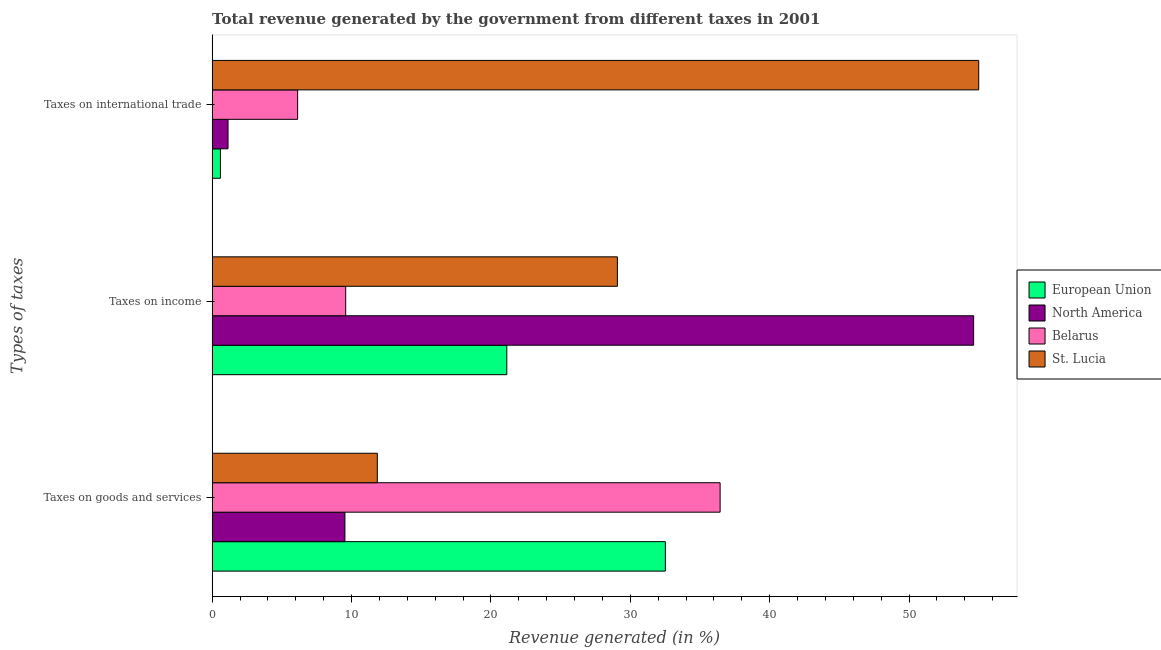How many groups of bars are there?
Provide a succinct answer. 3. How many bars are there on the 3rd tick from the top?
Offer a very short reply. 4. How many bars are there on the 2nd tick from the bottom?
Your answer should be very brief. 4. What is the label of the 2nd group of bars from the top?
Make the answer very short. Taxes on income. What is the percentage of revenue generated by taxes on income in St. Lucia?
Offer a very short reply. 29.08. Across all countries, what is the maximum percentage of revenue generated by taxes on income?
Offer a terse response. 54.64. Across all countries, what is the minimum percentage of revenue generated by taxes on income?
Offer a very short reply. 9.58. In which country was the percentage of revenue generated by taxes on goods and services minimum?
Your answer should be compact. North America. What is the total percentage of revenue generated by taxes on goods and services in the graph?
Make the answer very short. 90.35. What is the difference between the percentage of revenue generated by taxes on income in St. Lucia and that in Belarus?
Your response must be concise. 19.5. What is the difference between the percentage of revenue generated by taxes on goods and services in St. Lucia and the percentage of revenue generated by tax on international trade in European Union?
Your answer should be very brief. 11.26. What is the average percentage of revenue generated by taxes on goods and services per country?
Your answer should be compact. 22.59. What is the difference between the percentage of revenue generated by taxes on goods and services and percentage of revenue generated by tax on international trade in Belarus?
Your answer should be compact. 30.31. What is the ratio of the percentage of revenue generated by taxes on goods and services in European Union to that in St. Lucia?
Keep it short and to the point. 2.74. Is the difference between the percentage of revenue generated by taxes on goods and services in Belarus and European Union greater than the difference between the percentage of revenue generated by taxes on income in Belarus and European Union?
Provide a succinct answer. Yes. What is the difference between the highest and the second highest percentage of revenue generated by taxes on goods and services?
Give a very brief answer. 3.93. What is the difference between the highest and the lowest percentage of revenue generated by taxes on income?
Offer a very short reply. 45.05. What does the 4th bar from the bottom in Taxes on income represents?
Keep it short and to the point. St. Lucia. Is it the case that in every country, the sum of the percentage of revenue generated by taxes on goods and services and percentage of revenue generated by taxes on income is greater than the percentage of revenue generated by tax on international trade?
Your answer should be very brief. No. How many bars are there?
Your answer should be very brief. 12. How many countries are there in the graph?
Give a very brief answer. 4. Are the values on the major ticks of X-axis written in scientific E-notation?
Your response must be concise. No. Does the graph contain any zero values?
Your answer should be very brief. No. What is the title of the graph?
Your answer should be very brief. Total revenue generated by the government from different taxes in 2001. Does "Chile" appear as one of the legend labels in the graph?
Your answer should be very brief. No. What is the label or title of the X-axis?
Give a very brief answer. Revenue generated (in %). What is the label or title of the Y-axis?
Give a very brief answer. Types of taxes. What is the Revenue generated (in %) of European Union in Taxes on goods and services?
Offer a terse response. 32.52. What is the Revenue generated (in %) in North America in Taxes on goods and services?
Provide a short and direct response. 9.53. What is the Revenue generated (in %) in Belarus in Taxes on goods and services?
Your answer should be very brief. 36.45. What is the Revenue generated (in %) of St. Lucia in Taxes on goods and services?
Ensure brevity in your answer.  11.85. What is the Revenue generated (in %) of European Union in Taxes on income?
Provide a short and direct response. 21.14. What is the Revenue generated (in %) in North America in Taxes on income?
Provide a short and direct response. 54.64. What is the Revenue generated (in %) in Belarus in Taxes on income?
Provide a succinct answer. 9.58. What is the Revenue generated (in %) in St. Lucia in Taxes on income?
Your response must be concise. 29.08. What is the Revenue generated (in %) in European Union in Taxes on international trade?
Make the answer very short. 0.6. What is the Revenue generated (in %) of North America in Taxes on international trade?
Ensure brevity in your answer.  1.14. What is the Revenue generated (in %) in Belarus in Taxes on international trade?
Ensure brevity in your answer.  6.13. What is the Revenue generated (in %) in St. Lucia in Taxes on international trade?
Keep it short and to the point. 55. Across all Types of taxes, what is the maximum Revenue generated (in %) in European Union?
Your answer should be very brief. 32.52. Across all Types of taxes, what is the maximum Revenue generated (in %) in North America?
Offer a very short reply. 54.64. Across all Types of taxes, what is the maximum Revenue generated (in %) in Belarus?
Provide a succinct answer. 36.45. Across all Types of taxes, what is the maximum Revenue generated (in %) in St. Lucia?
Keep it short and to the point. 55. Across all Types of taxes, what is the minimum Revenue generated (in %) in European Union?
Offer a very short reply. 0.6. Across all Types of taxes, what is the minimum Revenue generated (in %) of North America?
Your answer should be very brief. 1.14. Across all Types of taxes, what is the minimum Revenue generated (in %) in Belarus?
Ensure brevity in your answer.  6.13. Across all Types of taxes, what is the minimum Revenue generated (in %) in St. Lucia?
Offer a terse response. 11.85. What is the total Revenue generated (in %) in European Union in the graph?
Ensure brevity in your answer.  54.26. What is the total Revenue generated (in %) in North America in the graph?
Make the answer very short. 65.31. What is the total Revenue generated (in %) of Belarus in the graph?
Your response must be concise. 52.17. What is the total Revenue generated (in %) of St. Lucia in the graph?
Ensure brevity in your answer.  95.93. What is the difference between the Revenue generated (in %) of European Union in Taxes on goods and services and that in Taxes on income?
Provide a succinct answer. 11.38. What is the difference between the Revenue generated (in %) of North America in Taxes on goods and services and that in Taxes on income?
Provide a succinct answer. -45.11. What is the difference between the Revenue generated (in %) of Belarus in Taxes on goods and services and that in Taxes on income?
Keep it short and to the point. 26.87. What is the difference between the Revenue generated (in %) of St. Lucia in Taxes on goods and services and that in Taxes on income?
Offer a terse response. -17.22. What is the difference between the Revenue generated (in %) in European Union in Taxes on goods and services and that in Taxes on international trade?
Keep it short and to the point. 31.92. What is the difference between the Revenue generated (in %) of North America in Taxes on goods and services and that in Taxes on international trade?
Make the answer very short. 8.39. What is the difference between the Revenue generated (in %) of Belarus in Taxes on goods and services and that in Taxes on international trade?
Provide a short and direct response. 30.31. What is the difference between the Revenue generated (in %) of St. Lucia in Taxes on goods and services and that in Taxes on international trade?
Your response must be concise. -43.15. What is the difference between the Revenue generated (in %) of European Union in Taxes on income and that in Taxes on international trade?
Offer a very short reply. 20.55. What is the difference between the Revenue generated (in %) of North America in Taxes on income and that in Taxes on international trade?
Offer a terse response. 53.5. What is the difference between the Revenue generated (in %) of Belarus in Taxes on income and that in Taxes on international trade?
Keep it short and to the point. 3.45. What is the difference between the Revenue generated (in %) of St. Lucia in Taxes on income and that in Taxes on international trade?
Your answer should be compact. -25.92. What is the difference between the Revenue generated (in %) in European Union in Taxes on goods and services and the Revenue generated (in %) in North America in Taxes on income?
Provide a succinct answer. -22.12. What is the difference between the Revenue generated (in %) in European Union in Taxes on goods and services and the Revenue generated (in %) in Belarus in Taxes on income?
Ensure brevity in your answer.  22.94. What is the difference between the Revenue generated (in %) of European Union in Taxes on goods and services and the Revenue generated (in %) of St. Lucia in Taxes on income?
Your answer should be compact. 3.44. What is the difference between the Revenue generated (in %) of North America in Taxes on goods and services and the Revenue generated (in %) of Belarus in Taxes on income?
Give a very brief answer. -0.05. What is the difference between the Revenue generated (in %) of North America in Taxes on goods and services and the Revenue generated (in %) of St. Lucia in Taxes on income?
Keep it short and to the point. -19.55. What is the difference between the Revenue generated (in %) of Belarus in Taxes on goods and services and the Revenue generated (in %) of St. Lucia in Taxes on income?
Keep it short and to the point. 7.37. What is the difference between the Revenue generated (in %) in European Union in Taxes on goods and services and the Revenue generated (in %) in North America in Taxes on international trade?
Your answer should be very brief. 31.38. What is the difference between the Revenue generated (in %) in European Union in Taxes on goods and services and the Revenue generated (in %) in Belarus in Taxes on international trade?
Give a very brief answer. 26.38. What is the difference between the Revenue generated (in %) of European Union in Taxes on goods and services and the Revenue generated (in %) of St. Lucia in Taxes on international trade?
Your answer should be compact. -22.48. What is the difference between the Revenue generated (in %) in North America in Taxes on goods and services and the Revenue generated (in %) in Belarus in Taxes on international trade?
Your answer should be compact. 3.39. What is the difference between the Revenue generated (in %) in North America in Taxes on goods and services and the Revenue generated (in %) in St. Lucia in Taxes on international trade?
Your response must be concise. -45.47. What is the difference between the Revenue generated (in %) in Belarus in Taxes on goods and services and the Revenue generated (in %) in St. Lucia in Taxes on international trade?
Ensure brevity in your answer.  -18.55. What is the difference between the Revenue generated (in %) of European Union in Taxes on income and the Revenue generated (in %) of North America in Taxes on international trade?
Offer a terse response. 20. What is the difference between the Revenue generated (in %) of European Union in Taxes on income and the Revenue generated (in %) of Belarus in Taxes on international trade?
Make the answer very short. 15.01. What is the difference between the Revenue generated (in %) in European Union in Taxes on income and the Revenue generated (in %) in St. Lucia in Taxes on international trade?
Keep it short and to the point. -33.86. What is the difference between the Revenue generated (in %) in North America in Taxes on income and the Revenue generated (in %) in Belarus in Taxes on international trade?
Make the answer very short. 48.5. What is the difference between the Revenue generated (in %) in North America in Taxes on income and the Revenue generated (in %) in St. Lucia in Taxes on international trade?
Your answer should be compact. -0.36. What is the difference between the Revenue generated (in %) of Belarus in Taxes on income and the Revenue generated (in %) of St. Lucia in Taxes on international trade?
Ensure brevity in your answer.  -45.42. What is the average Revenue generated (in %) of European Union per Types of taxes?
Ensure brevity in your answer.  18.09. What is the average Revenue generated (in %) in North America per Types of taxes?
Offer a terse response. 21.77. What is the average Revenue generated (in %) in Belarus per Types of taxes?
Give a very brief answer. 17.39. What is the average Revenue generated (in %) of St. Lucia per Types of taxes?
Keep it short and to the point. 31.98. What is the difference between the Revenue generated (in %) of European Union and Revenue generated (in %) of North America in Taxes on goods and services?
Keep it short and to the point. 22.99. What is the difference between the Revenue generated (in %) of European Union and Revenue generated (in %) of Belarus in Taxes on goods and services?
Your answer should be very brief. -3.93. What is the difference between the Revenue generated (in %) of European Union and Revenue generated (in %) of St. Lucia in Taxes on goods and services?
Provide a short and direct response. 20.67. What is the difference between the Revenue generated (in %) in North America and Revenue generated (in %) in Belarus in Taxes on goods and services?
Your answer should be compact. -26.92. What is the difference between the Revenue generated (in %) of North America and Revenue generated (in %) of St. Lucia in Taxes on goods and services?
Ensure brevity in your answer.  -2.32. What is the difference between the Revenue generated (in %) in Belarus and Revenue generated (in %) in St. Lucia in Taxes on goods and services?
Your response must be concise. 24.6. What is the difference between the Revenue generated (in %) in European Union and Revenue generated (in %) in North America in Taxes on income?
Offer a very short reply. -33.5. What is the difference between the Revenue generated (in %) in European Union and Revenue generated (in %) in Belarus in Taxes on income?
Provide a succinct answer. 11.56. What is the difference between the Revenue generated (in %) in European Union and Revenue generated (in %) in St. Lucia in Taxes on income?
Make the answer very short. -7.94. What is the difference between the Revenue generated (in %) of North America and Revenue generated (in %) of Belarus in Taxes on income?
Your answer should be very brief. 45.05. What is the difference between the Revenue generated (in %) of North America and Revenue generated (in %) of St. Lucia in Taxes on income?
Your answer should be very brief. 25.56. What is the difference between the Revenue generated (in %) in Belarus and Revenue generated (in %) in St. Lucia in Taxes on income?
Keep it short and to the point. -19.5. What is the difference between the Revenue generated (in %) in European Union and Revenue generated (in %) in North America in Taxes on international trade?
Your answer should be very brief. -0.55. What is the difference between the Revenue generated (in %) in European Union and Revenue generated (in %) in Belarus in Taxes on international trade?
Make the answer very short. -5.54. What is the difference between the Revenue generated (in %) in European Union and Revenue generated (in %) in St. Lucia in Taxes on international trade?
Your response must be concise. -54.41. What is the difference between the Revenue generated (in %) of North America and Revenue generated (in %) of Belarus in Taxes on international trade?
Offer a very short reply. -4.99. What is the difference between the Revenue generated (in %) of North America and Revenue generated (in %) of St. Lucia in Taxes on international trade?
Offer a very short reply. -53.86. What is the difference between the Revenue generated (in %) of Belarus and Revenue generated (in %) of St. Lucia in Taxes on international trade?
Your answer should be very brief. -48.87. What is the ratio of the Revenue generated (in %) of European Union in Taxes on goods and services to that in Taxes on income?
Your answer should be very brief. 1.54. What is the ratio of the Revenue generated (in %) in North America in Taxes on goods and services to that in Taxes on income?
Offer a very short reply. 0.17. What is the ratio of the Revenue generated (in %) in Belarus in Taxes on goods and services to that in Taxes on income?
Ensure brevity in your answer.  3.8. What is the ratio of the Revenue generated (in %) in St. Lucia in Taxes on goods and services to that in Taxes on income?
Give a very brief answer. 0.41. What is the ratio of the Revenue generated (in %) of European Union in Taxes on goods and services to that in Taxes on international trade?
Your answer should be very brief. 54.62. What is the ratio of the Revenue generated (in %) in North America in Taxes on goods and services to that in Taxes on international trade?
Provide a succinct answer. 8.35. What is the ratio of the Revenue generated (in %) in Belarus in Taxes on goods and services to that in Taxes on international trade?
Offer a terse response. 5.94. What is the ratio of the Revenue generated (in %) in St. Lucia in Taxes on goods and services to that in Taxes on international trade?
Offer a terse response. 0.22. What is the ratio of the Revenue generated (in %) in European Union in Taxes on income to that in Taxes on international trade?
Keep it short and to the point. 35.51. What is the ratio of the Revenue generated (in %) of North America in Taxes on income to that in Taxes on international trade?
Provide a short and direct response. 47.87. What is the ratio of the Revenue generated (in %) in Belarus in Taxes on income to that in Taxes on international trade?
Offer a terse response. 1.56. What is the ratio of the Revenue generated (in %) in St. Lucia in Taxes on income to that in Taxes on international trade?
Ensure brevity in your answer.  0.53. What is the difference between the highest and the second highest Revenue generated (in %) in European Union?
Your answer should be compact. 11.38. What is the difference between the highest and the second highest Revenue generated (in %) in North America?
Provide a succinct answer. 45.11. What is the difference between the highest and the second highest Revenue generated (in %) of Belarus?
Keep it short and to the point. 26.87. What is the difference between the highest and the second highest Revenue generated (in %) of St. Lucia?
Your answer should be very brief. 25.92. What is the difference between the highest and the lowest Revenue generated (in %) of European Union?
Your answer should be very brief. 31.92. What is the difference between the highest and the lowest Revenue generated (in %) of North America?
Your answer should be very brief. 53.5. What is the difference between the highest and the lowest Revenue generated (in %) in Belarus?
Offer a terse response. 30.31. What is the difference between the highest and the lowest Revenue generated (in %) in St. Lucia?
Your answer should be very brief. 43.15. 